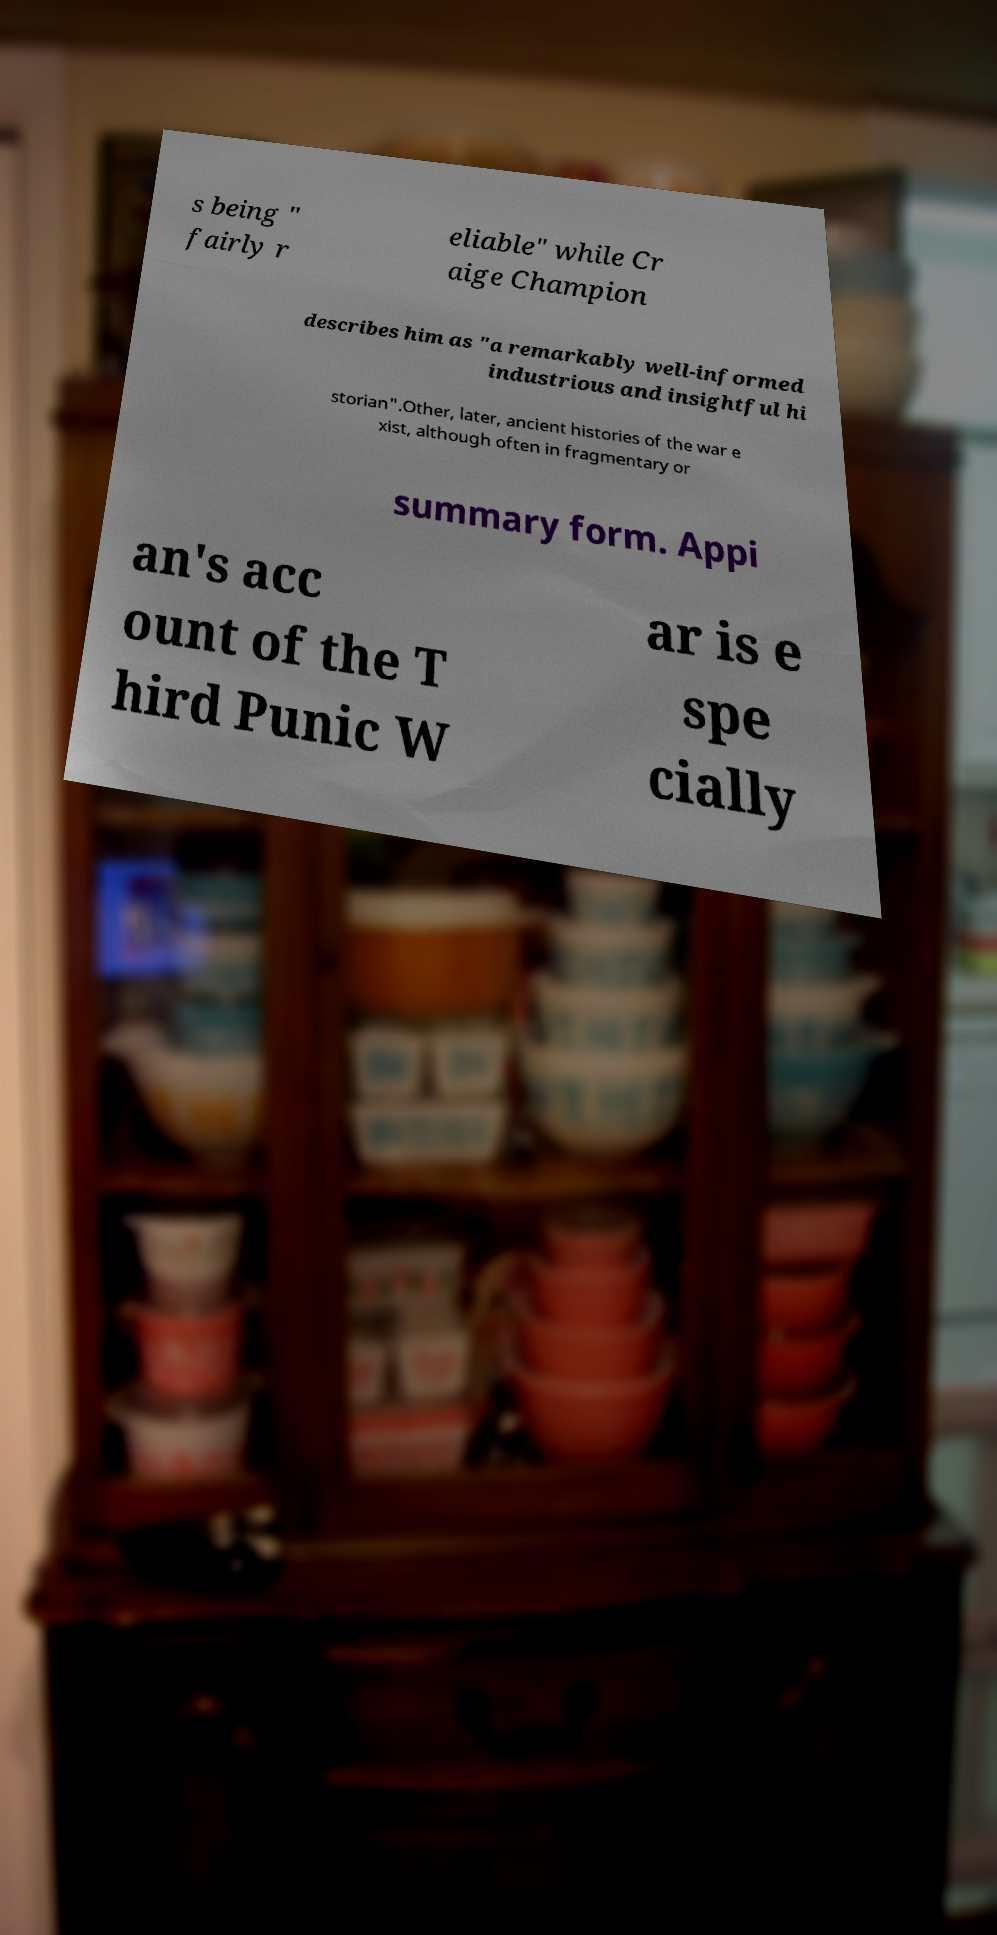For documentation purposes, I need the text within this image transcribed. Could you provide that? s being " fairly r eliable" while Cr aige Champion describes him as "a remarkably well-informed industrious and insightful hi storian".Other, later, ancient histories of the war e xist, although often in fragmentary or summary form. Appi an's acc ount of the T hird Punic W ar is e spe cially 